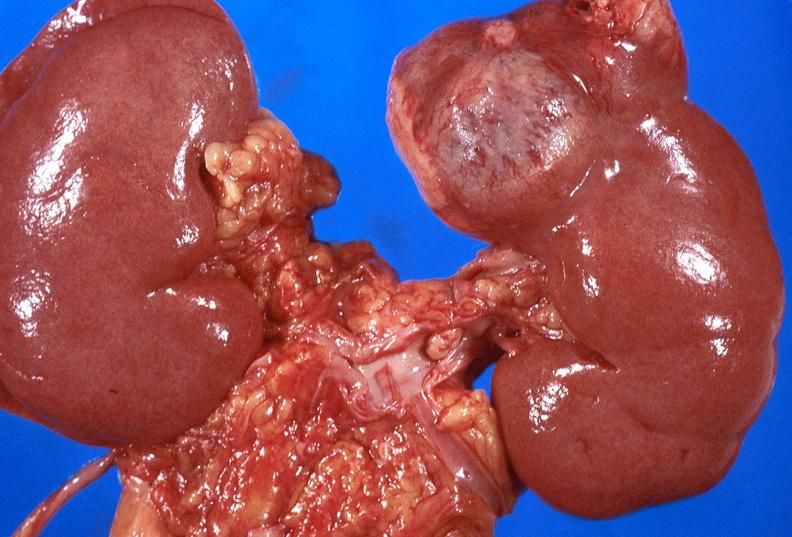what does this image show?
Answer the question using a single word or phrase. Renal cell carcinoma with extension into vena cava 